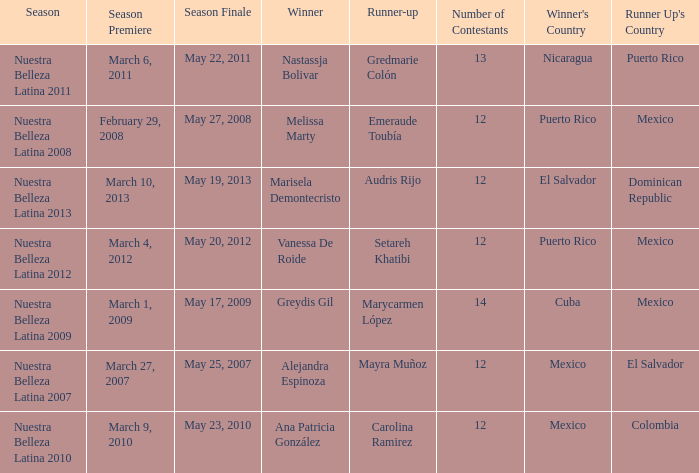How many contestants were there in a season where alejandra espinoza won? 1.0. 